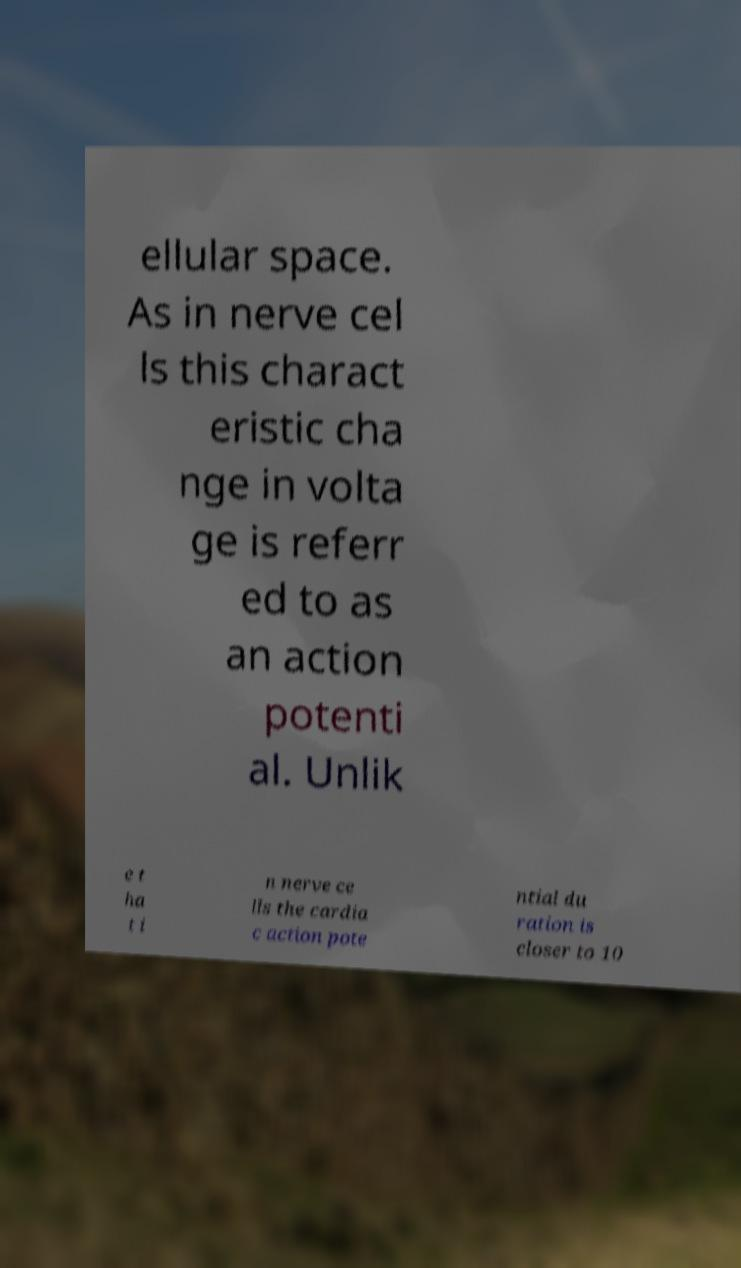Can you accurately transcribe the text from the provided image for me? ellular space. As in nerve cel ls this charact eristic cha nge in volta ge is referr ed to as an action potenti al. Unlik e t ha t i n nerve ce lls the cardia c action pote ntial du ration is closer to 10 